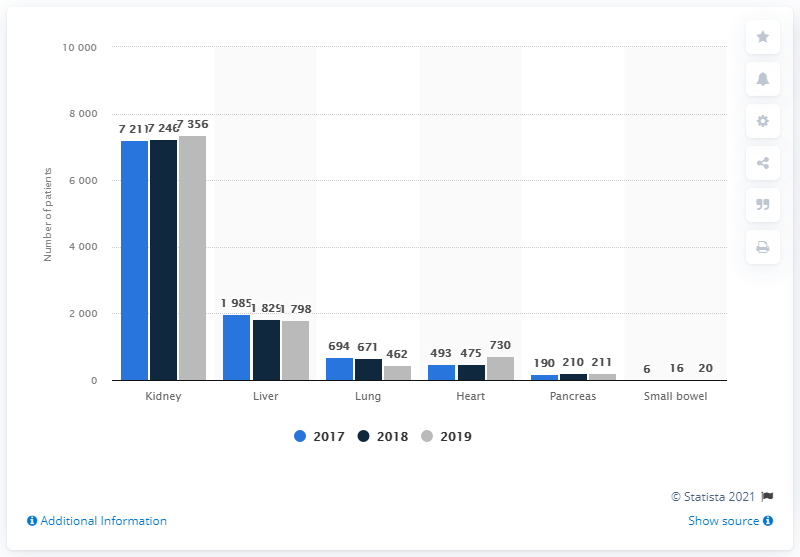Identify some key points in this picture. In 2019, there were 7,356 patients on the organ transplant waiting list for a kidney. 